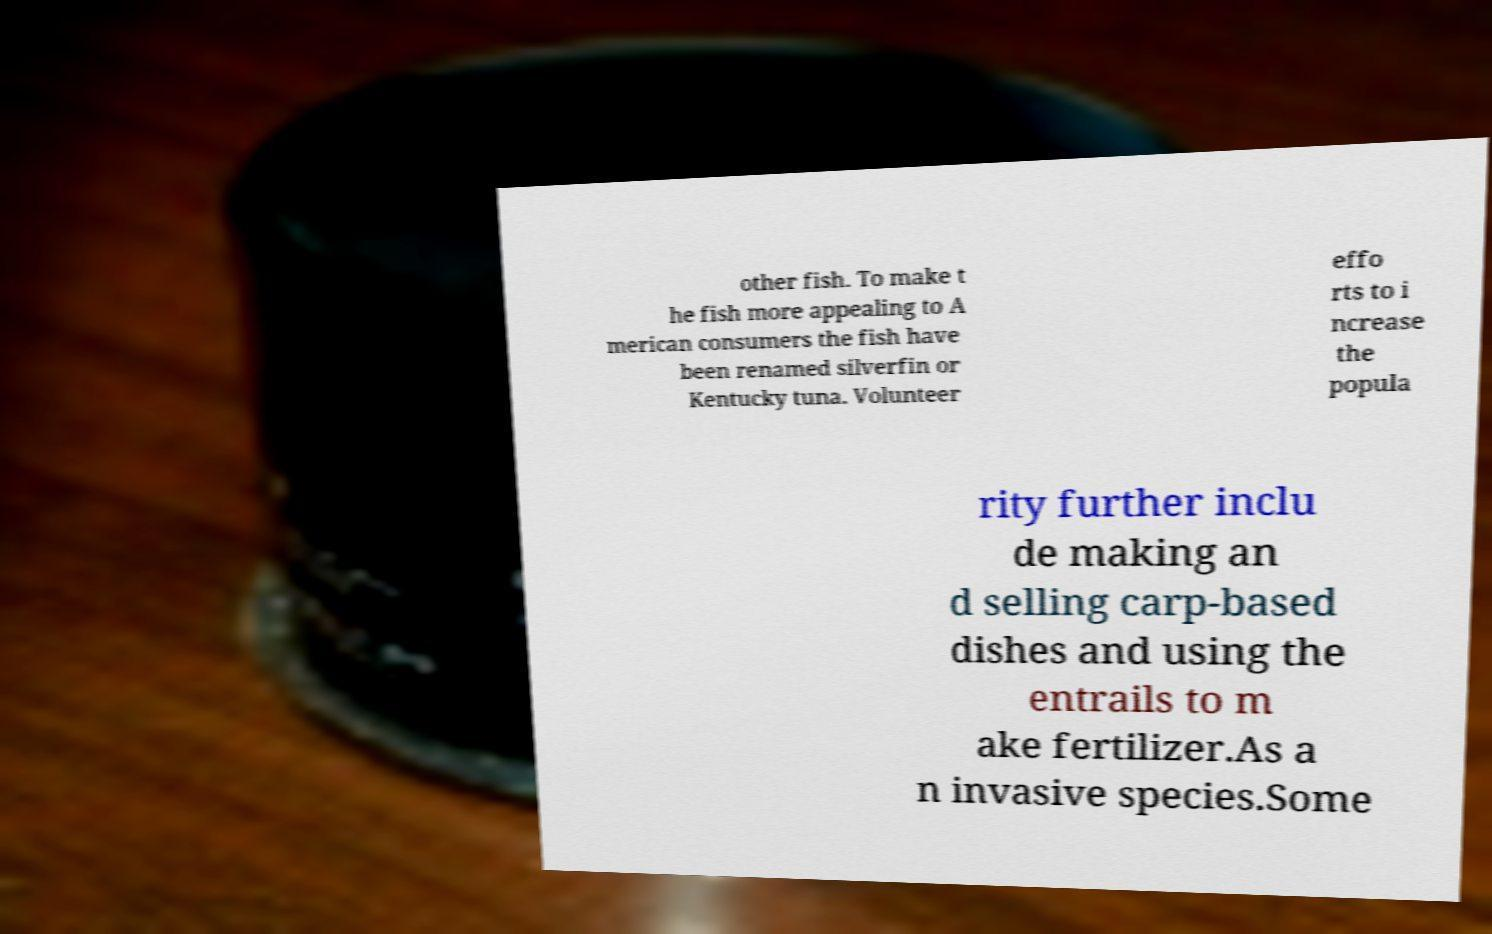Could you extract and type out the text from this image? other fish. To make t he fish more appealing to A merican consumers the fish have been renamed silverfin or Kentucky tuna. Volunteer effo rts to i ncrease the popula rity further inclu de making an d selling carp-based dishes and using the entrails to m ake fertilizer.As a n invasive species.Some 